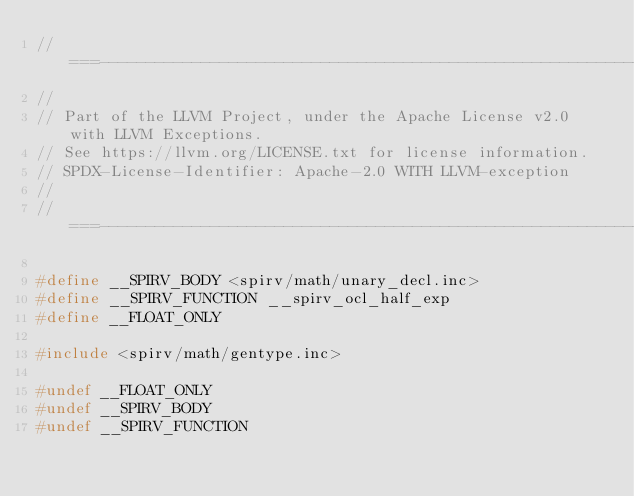Convert code to text. <code><loc_0><loc_0><loc_500><loc_500><_C_>//===----------------------------------------------------------------------===//
//
// Part of the LLVM Project, under the Apache License v2.0 with LLVM Exceptions.
// See https://llvm.org/LICENSE.txt for license information.
// SPDX-License-Identifier: Apache-2.0 WITH LLVM-exception
//
//===----------------------------------------------------------------------===//

#define __SPIRV_BODY <spirv/math/unary_decl.inc>
#define __SPIRV_FUNCTION __spirv_ocl_half_exp
#define __FLOAT_ONLY

#include <spirv/math/gentype.inc>

#undef __FLOAT_ONLY
#undef __SPIRV_BODY
#undef __SPIRV_FUNCTION
</code> 